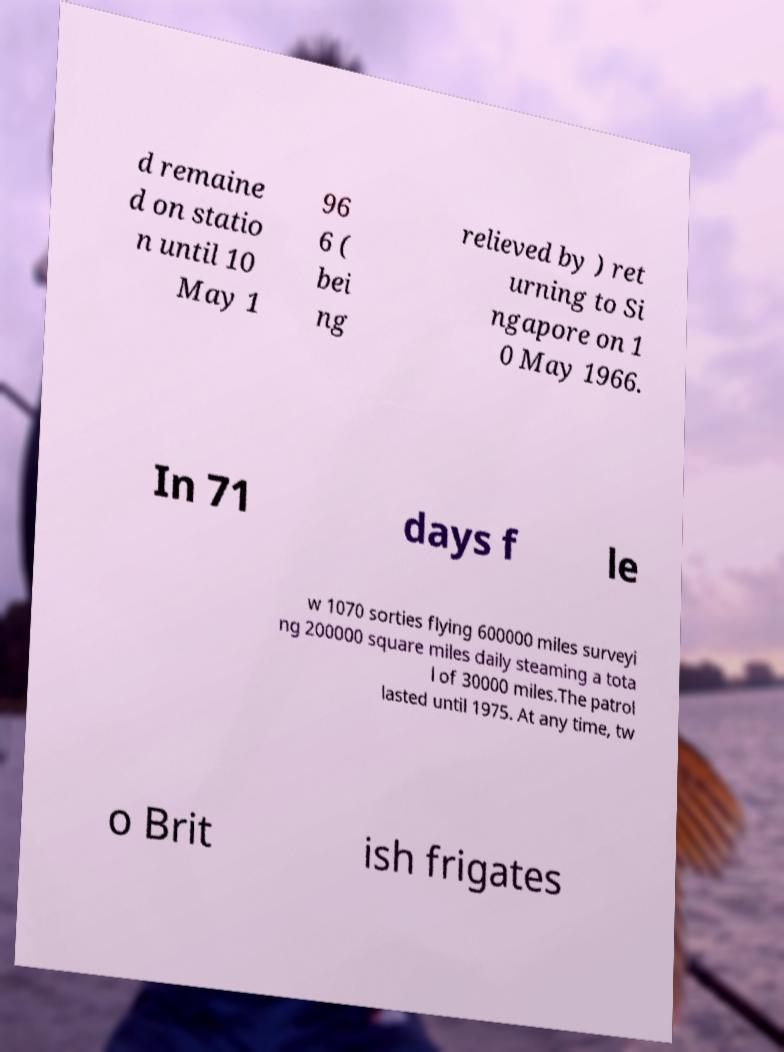I need the written content from this picture converted into text. Can you do that? d remaine d on statio n until 10 May 1 96 6 ( bei ng relieved by ) ret urning to Si ngapore on 1 0 May 1966. In 71 days f le w 1070 sorties flying 600000 miles surveyi ng 200000 square miles daily steaming a tota l of 30000 miles.The patrol lasted until 1975. At any time, tw o Brit ish frigates 